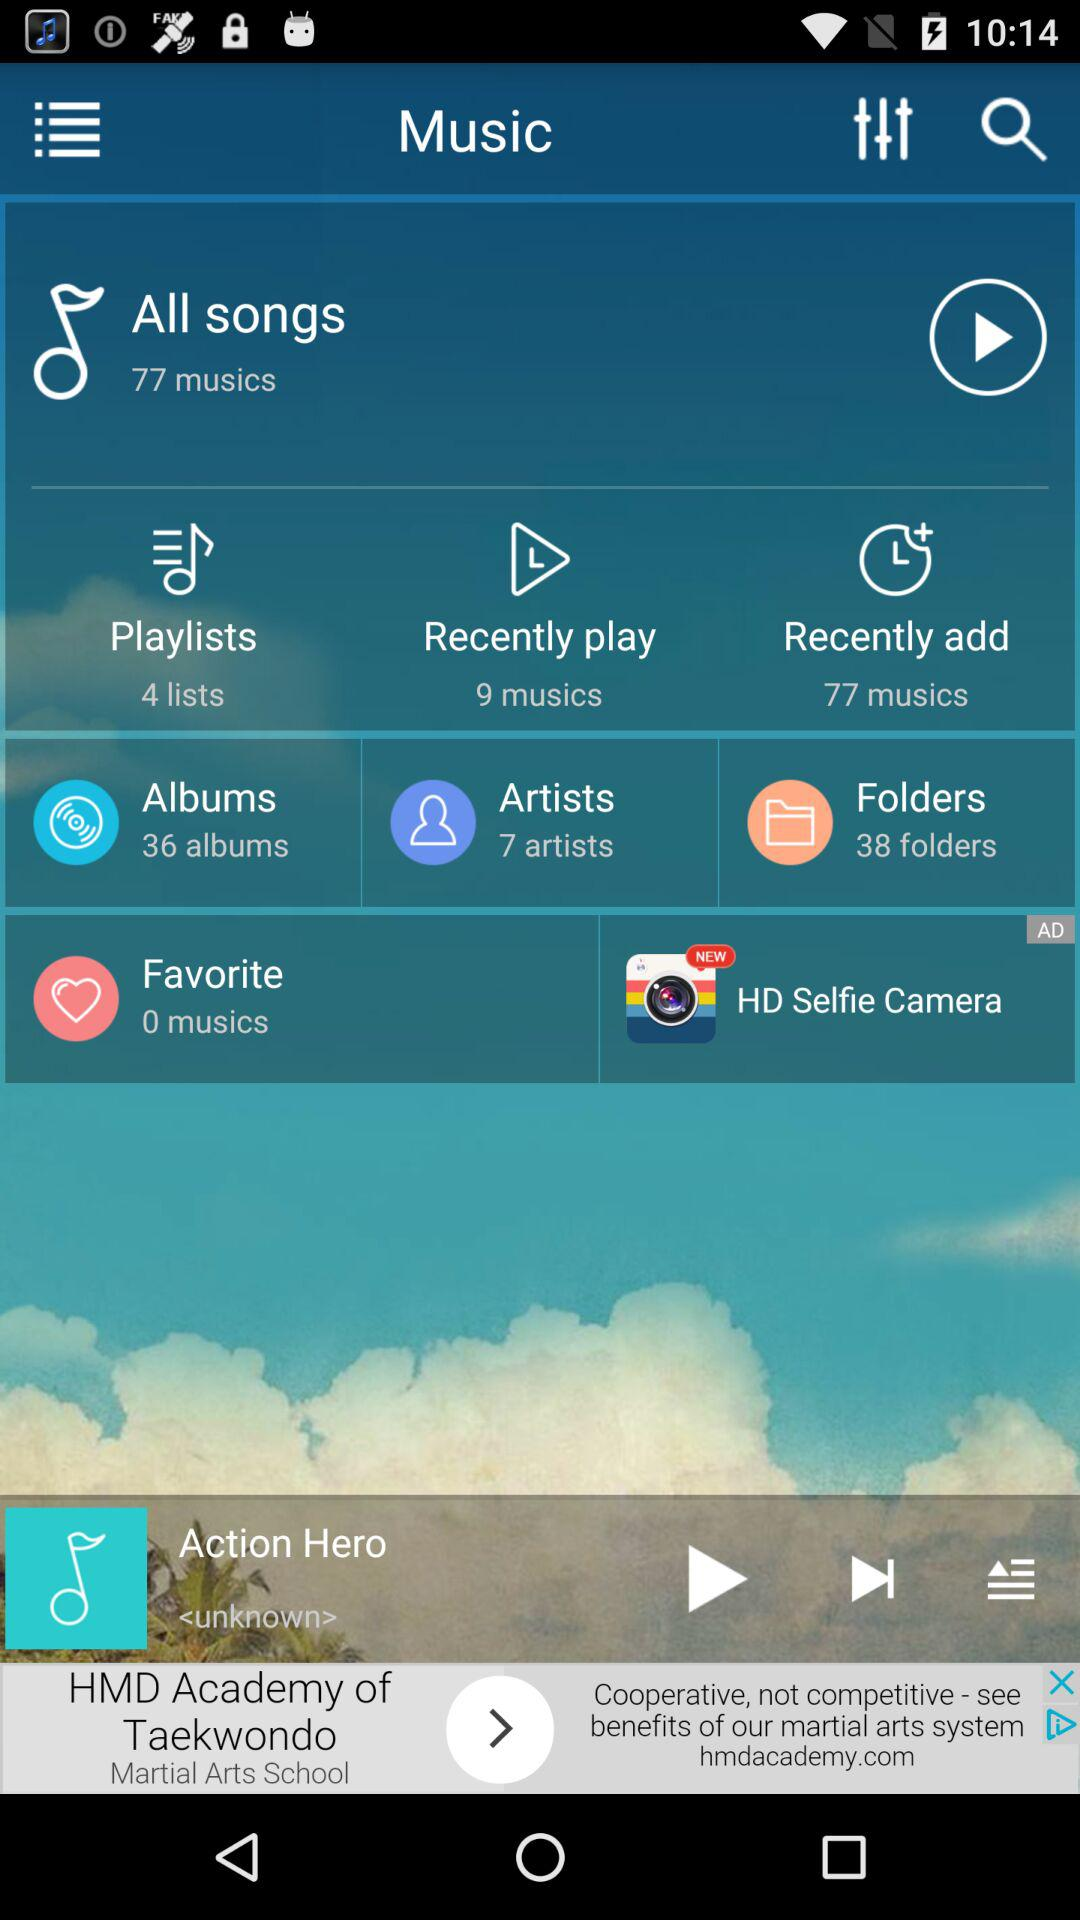Which music is currently playing? The music currently playing is Action Hero. 